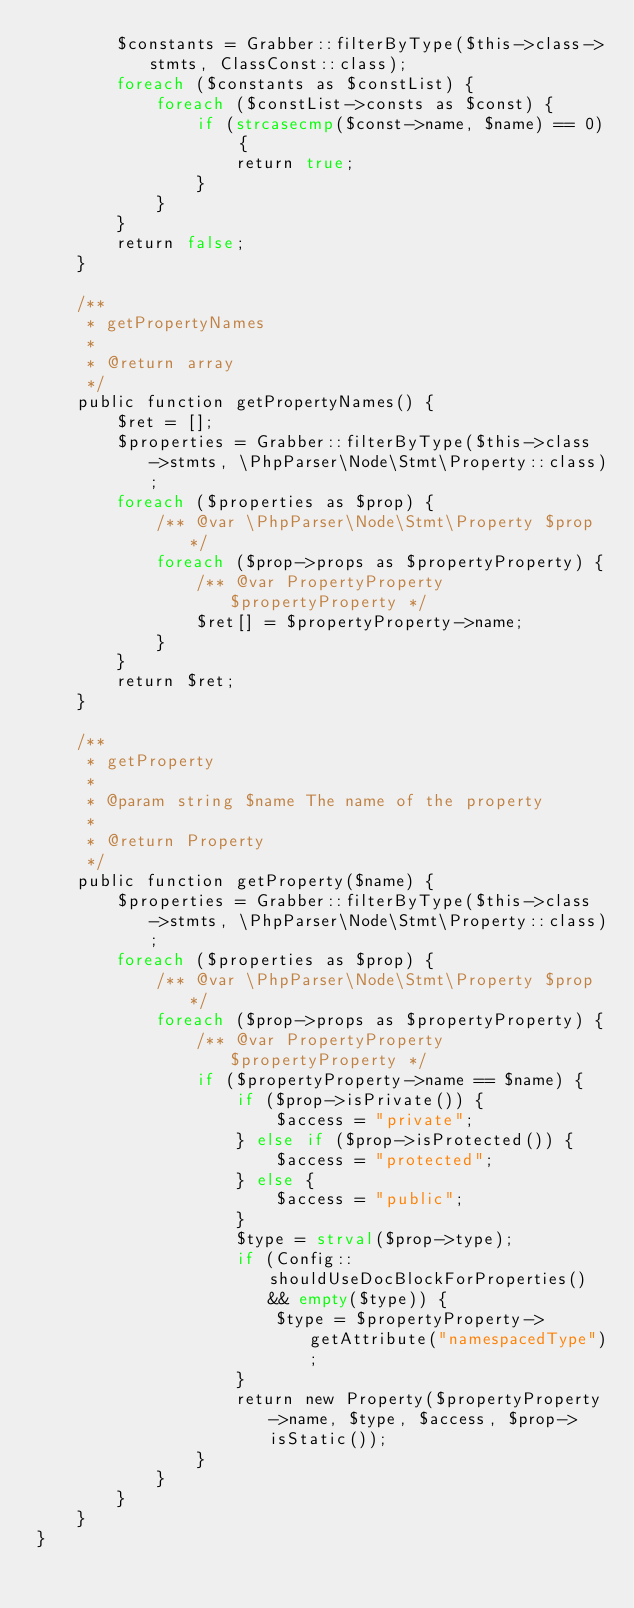<code> <loc_0><loc_0><loc_500><loc_500><_PHP_>		$constants = Grabber::filterByType($this->class->stmts, ClassConst::class);
		foreach ($constants as $constList) {
			foreach ($constList->consts as $const) {
				if (strcasecmp($const->name, $name) == 0) {
					return true;
				}
			}
		}
		return false;
	}

	/**
	 * getPropertyNames
	 *
	 * @return array
	 */
	public function getPropertyNames() {
		$ret = [];
		$properties = Grabber::filterByType($this->class->stmts, \PhpParser\Node\Stmt\Property::class);
		foreach ($properties as $prop) {
			/** @var \PhpParser\Node\Stmt\Property $prop */
			foreach ($prop->props as $propertyProperty) {
				/** @var PropertyProperty $propertyProperty */
				$ret[] = $propertyProperty->name;
			}
		}
		return $ret;
	}

	/**
	 * getProperty
	 *
	 * @param string $name The name of the property
	 *
	 * @return Property
	 */
	public function getProperty($name) {
		$properties = Grabber::filterByType($this->class->stmts, \PhpParser\Node\Stmt\Property::class);
		foreach ($properties as $prop) {
			/** @var \PhpParser\Node\Stmt\Property $prop */
			foreach ($prop->props as $propertyProperty) {
				/** @var PropertyProperty $propertyProperty */
				if ($propertyProperty->name == $name) {
					if ($prop->isPrivate()) {
						$access = "private";
					} else if ($prop->isProtected()) {
						$access = "protected";
					} else {
						$access = "public";
					}
					$type = strval($prop->type);
					if (Config::shouldUseDocBlockForProperties() && empty($type)) {
						$type = $propertyProperty->getAttribute("namespacedType");
					}
					return new Property($propertyProperty->name, $type, $access, $prop->isStatic());
				}
			}
		}
	}
}</code> 